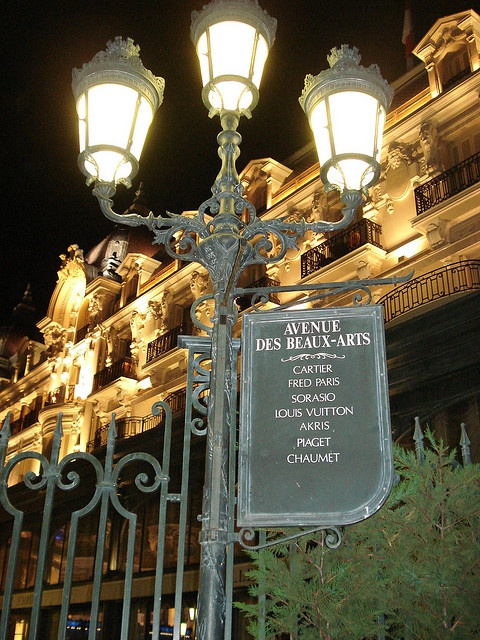Describe the objects in this image and their specific colors. I can see various objects in this image with different colors. 